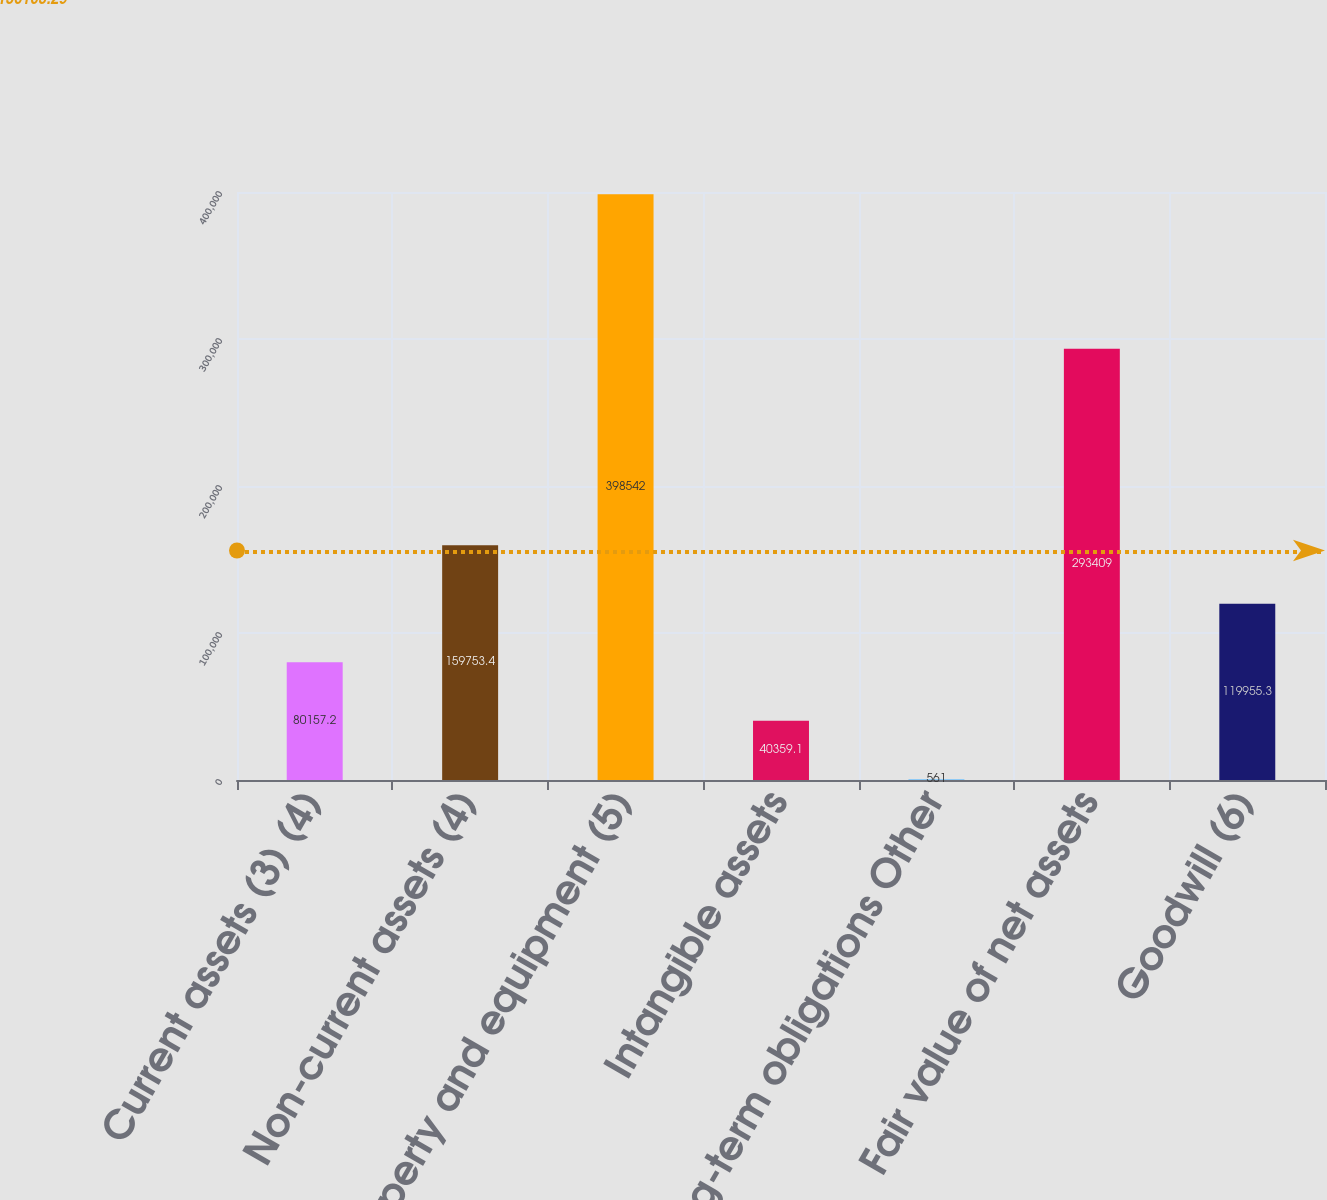<chart> <loc_0><loc_0><loc_500><loc_500><bar_chart><fcel>Current assets (3) (4)<fcel>Non-current assets (4)<fcel>Property and equipment (5)<fcel>Intangible assets<fcel>Long-term obligations Other<fcel>Fair value of net assets<fcel>Goodwill (6)<nl><fcel>80157.2<fcel>159753<fcel>398542<fcel>40359.1<fcel>561<fcel>293409<fcel>119955<nl></chart> 